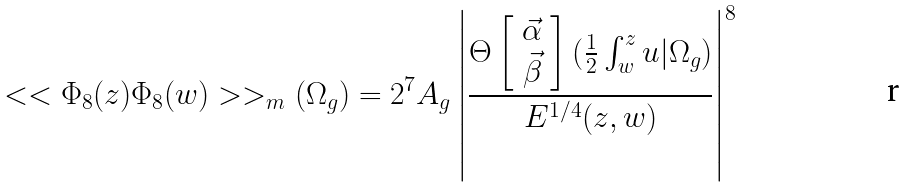Convert formula to latex. <formula><loc_0><loc_0><loc_500><loc_500>< < \Phi _ { 8 } ( z ) \Phi _ { 8 } ( w ) > > _ { m } ( \Omega _ { g } ) = 2 ^ { 7 } A _ { g } \left | \frac { \Theta \left [ \begin{array} { c } { \vec { \alpha } } \\ { \vec { \beta } } \end{array} \right ] ( \frac { 1 } { 2 } \int _ { w } ^ { z } { u } | \Omega _ { g } ) } { E ^ { 1 / 4 } ( z , w ) } \right | ^ { 8 }</formula> 